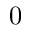<formula> <loc_0><loc_0><loc_500><loc_500>0</formula> 